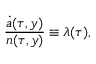Convert formula to latex. <formula><loc_0><loc_0><loc_500><loc_500>\frac { \dot { a } ( \tau , y ) } { n ( \tau , y ) } \equiv \lambda ( \tau ) ,</formula> 